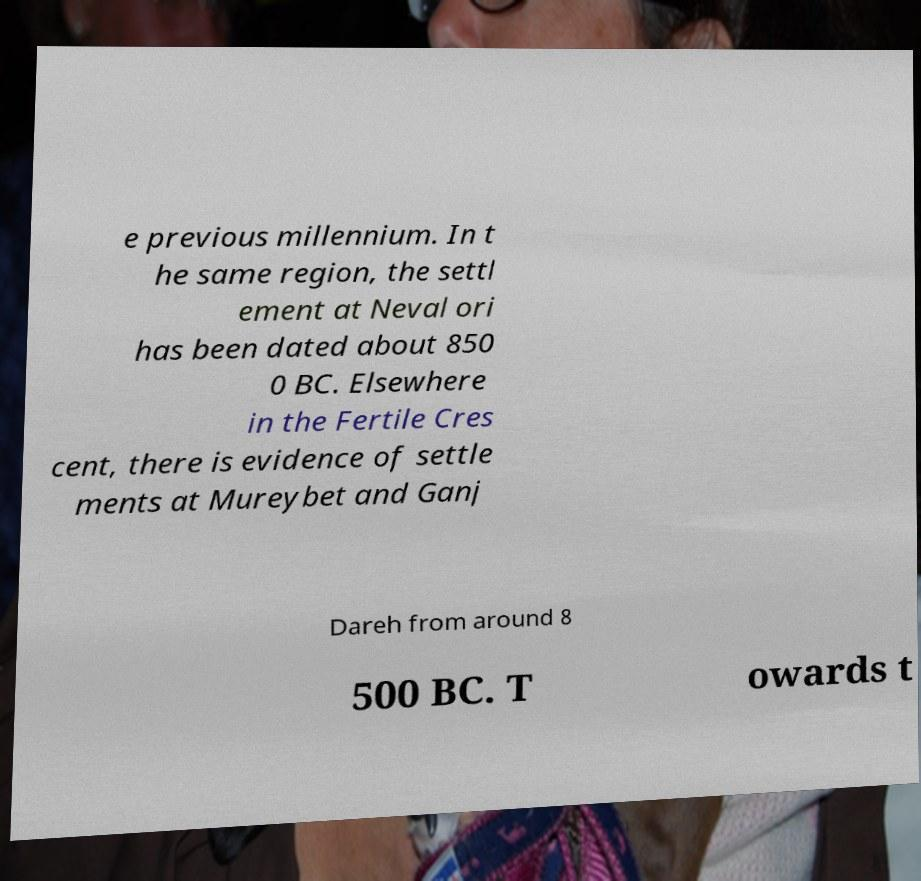There's text embedded in this image that I need extracted. Can you transcribe it verbatim? e previous millennium. In t he same region, the settl ement at Neval ori has been dated about 850 0 BC. Elsewhere in the Fertile Cres cent, there is evidence of settle ments at Mureybet and Ganj Dareh from around 8 500 BC. T owards t 